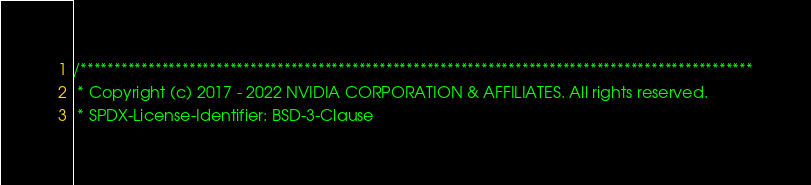Convert code to text. <code><loc_0><loc_0><loc_500><loc_500><_Cuda_>/***************************************************************************************************
 * Copyright (c) 2017 - 2022 NVIDIA CORPORATION & AFFILIATES. All rights reserved.
 * SPDX-License-Identifier: BSD-3-Clause</code> 